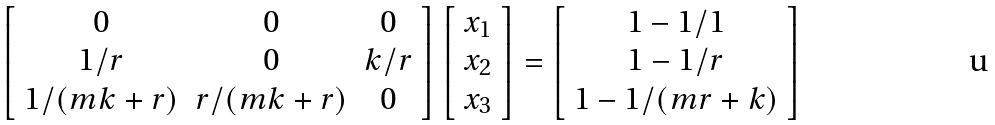Convert formula to latex. <formula><loc_0><loc_0><loc_500><loc_500>\left [ \begin{array} { c c c } 0 & 0 & 0 \\ 1 / r & 0 & k / r \\ 1 / ( m k + r ) & r / ( m k + r ) & 0 \end{array} \right ] \left [ \begin{array} { c } x _ { 1 } \\ x _ { 2 } \\ x _ { 3 } \end{array} \right ] = \left [ \begin{array} { c } 1 - 1 / 1 \\ 1 - 1 / r \\ 1 - 1 / ( m r + k ) \end{array} \right ]</formula> 